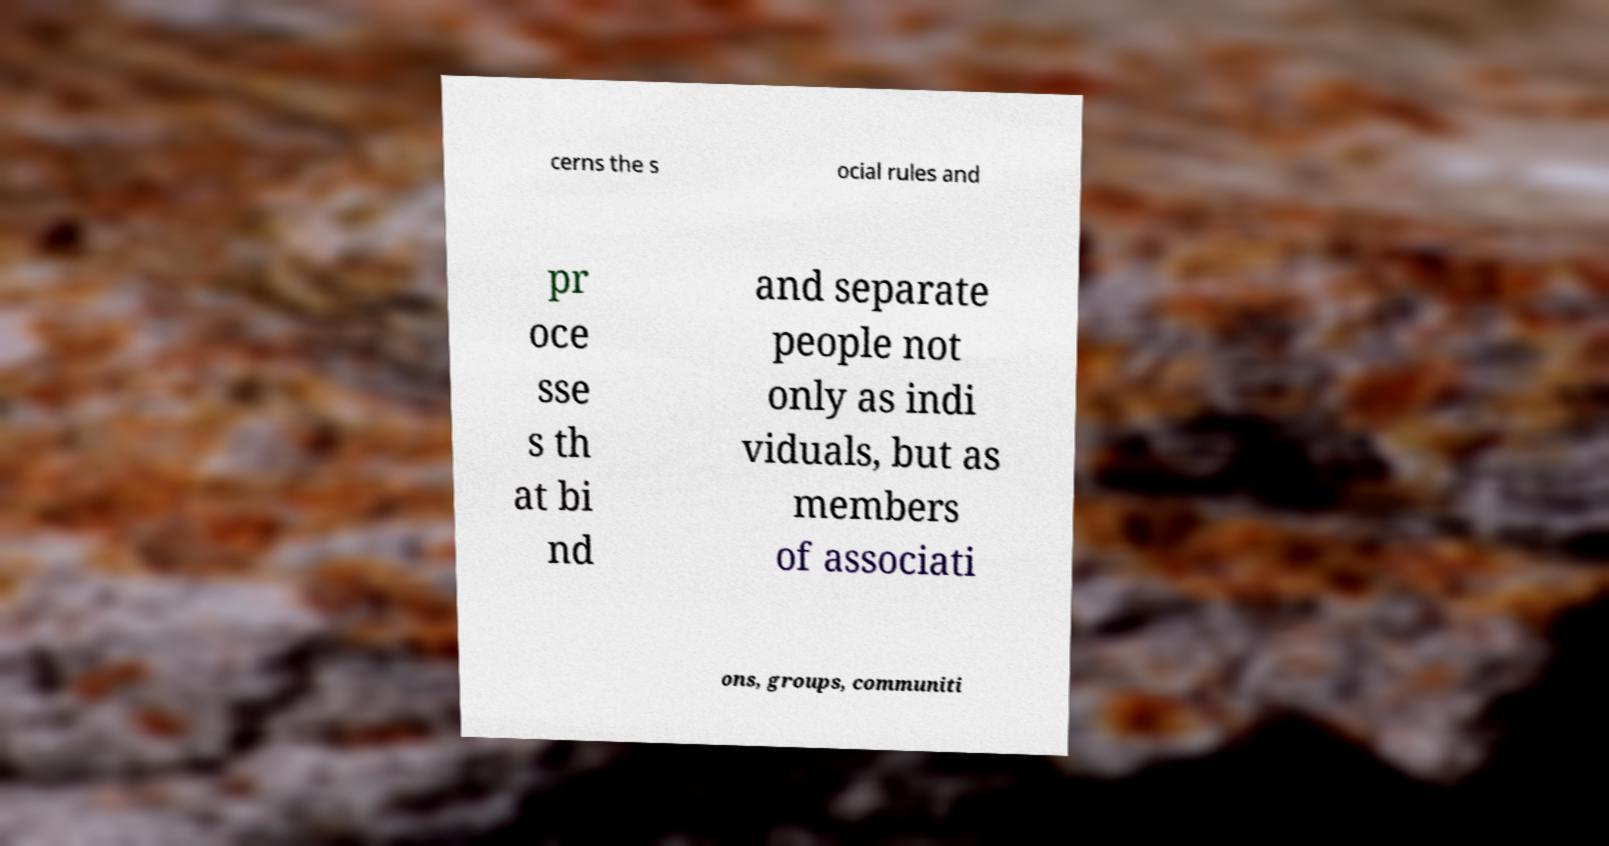Can you accurately transcribe the text from the provided image for me? cerns the s ocial rules and pr oce sse s th at bi nd and separate people not only as indi viduals, but as members of associati ons, groups, communiti 